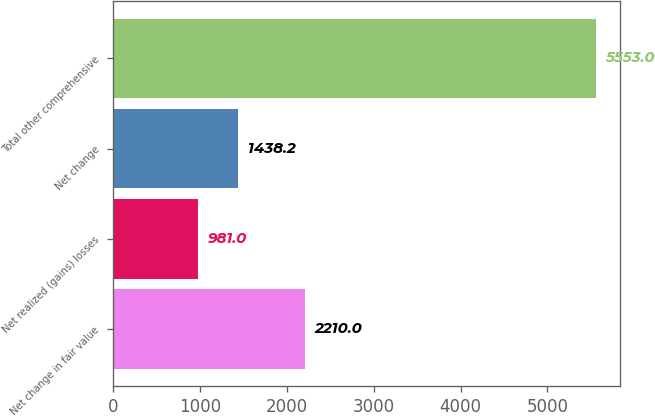Convert chart to OTSL. <chart><loc_0><loc_0><loc_500><loc_500><bar_chart><fcel>Net change in fair value<fcel>Net realized (gains) losses<fcel>Net change<fcel>Total other comprehensive<nl><fcel>2210<fcel>981<fcel>1438.2<fcel>5553<nl></chart> 